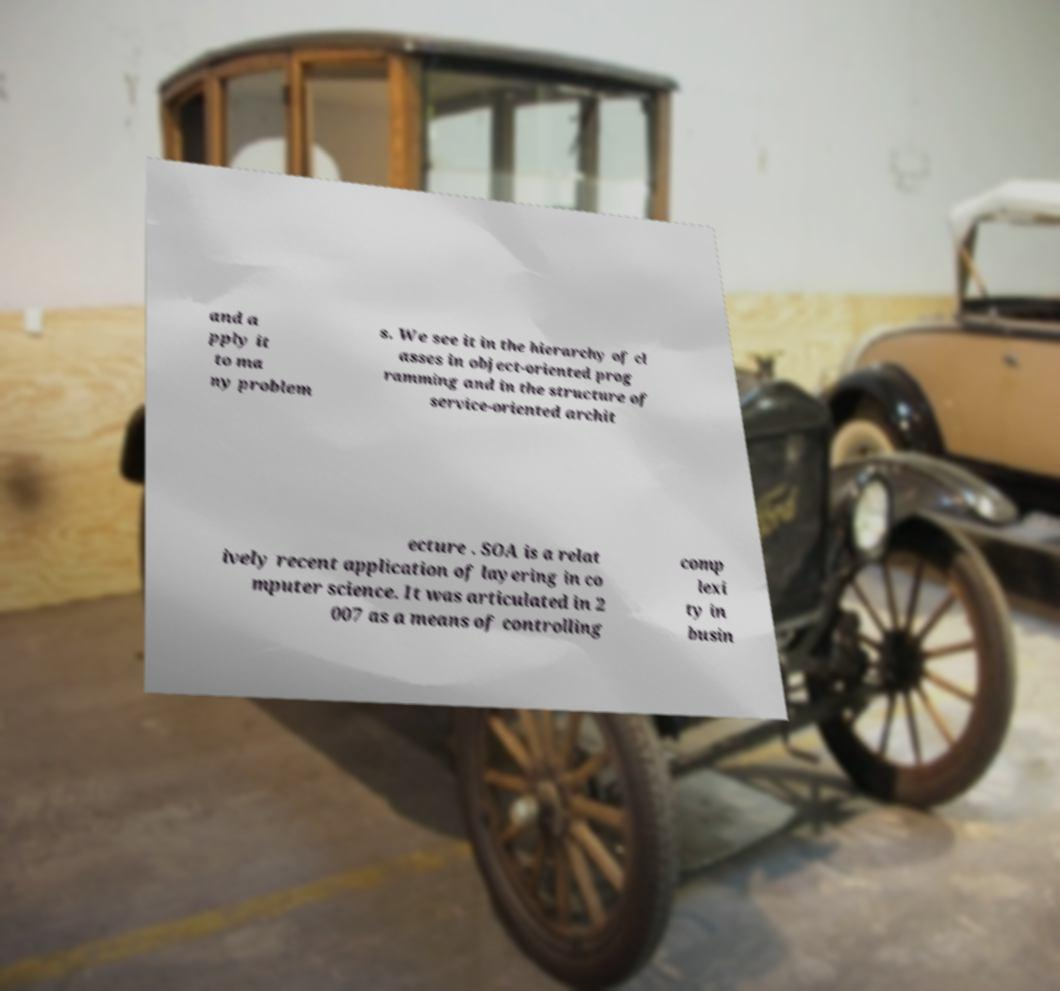Can you accurately transcribe the text from the provided image for me? and a pply it to ma ny problem s. We see it in the hierarchy of cl asses in object-oriented prog ramming and in the structure of service-oriented archit ecture . SOA is a relat ively recent application of layering in co mputer science. It was articulated in 2 007 as a means of controlling comp lexi ty in busin 